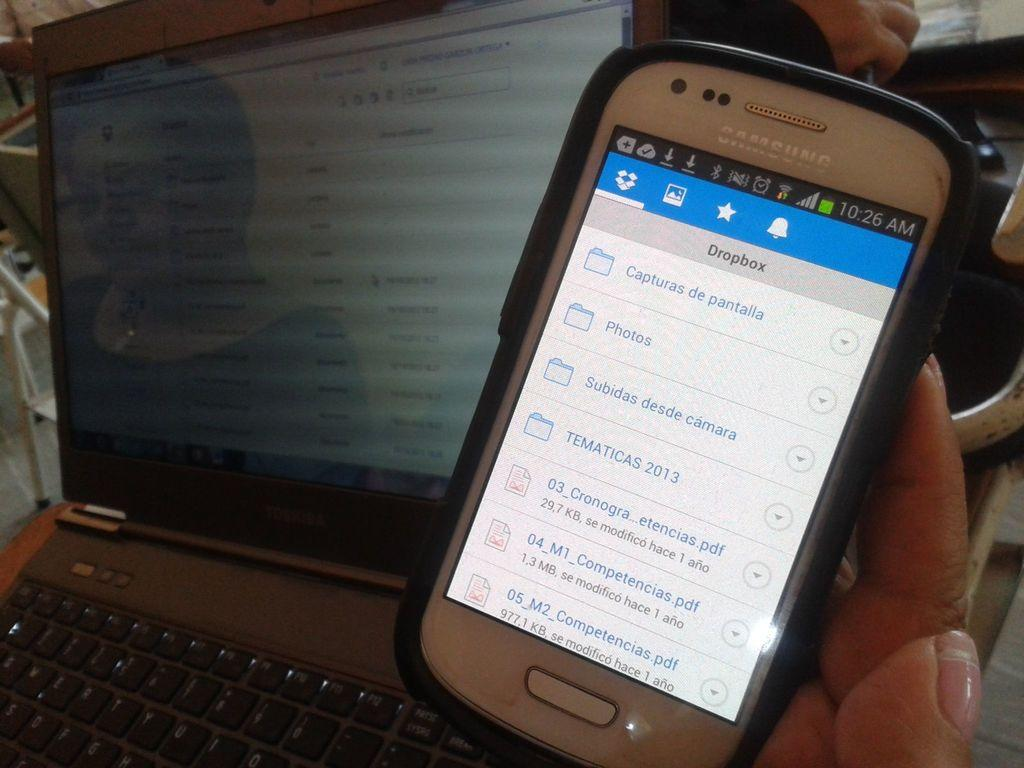<image>
Describe the image concisely. Someone holding a cellphone looking at their Dropbox scren. 